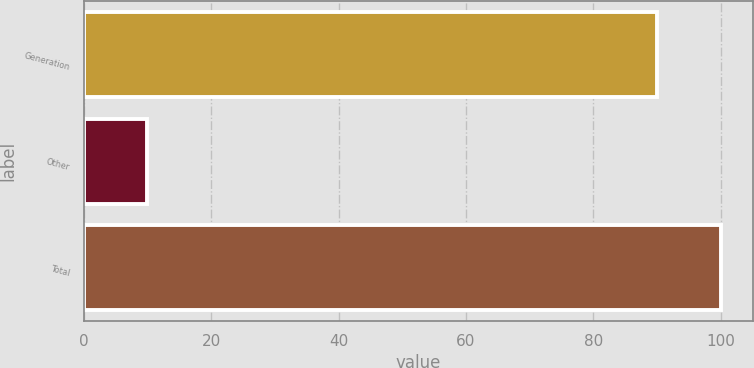Convert chart. <chart><loc_0><loc_0><loc_500><loc_500><bar_chart><fcel>Generation<fcel>Other<fcel>Total<nl><fcel>90<fcel>10<fcel>100<nl></chart> 